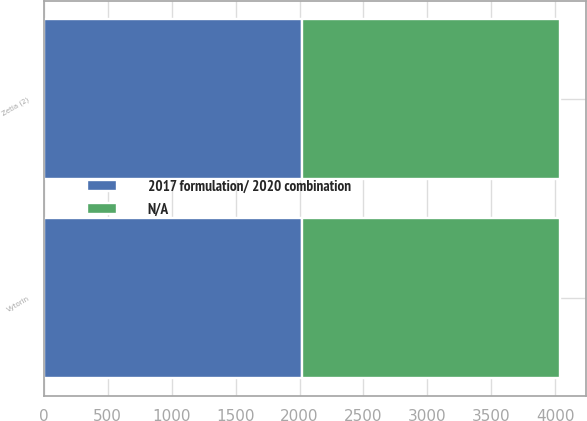Convert chart. <chart><loc_0><loc_0><loc_500><loc_500><stacked_bar_chart><ecel><fcel>Zetia (2)<fcel>Vytorin<nl><fcel>2017 formulation/ 2020 combination<fcel>2017<fcel>2017<nl><fcel>nan<fcel>2018<fcel>2019<nl></chart> 